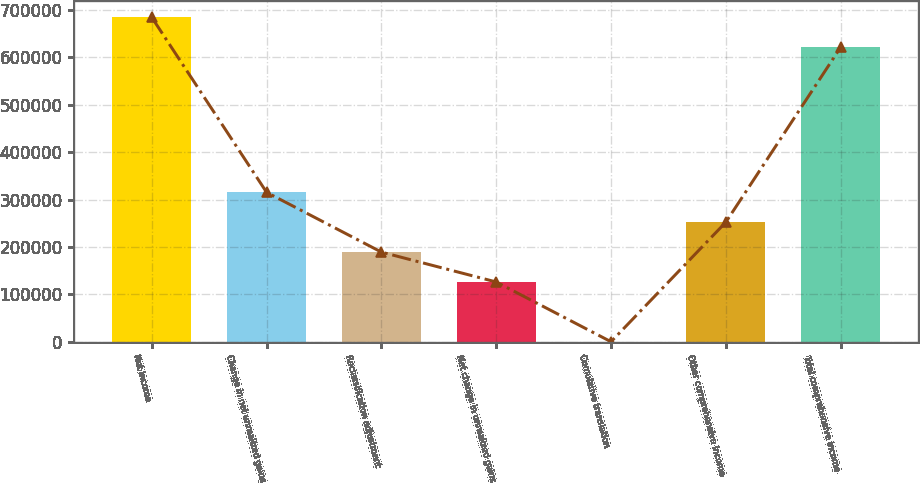Convert chart. <chart><loc_0><loc_0><loc_500><loc_500><bar_chart><fcel>Net income<fcel>Change in net unrealized gains<fcel>Reclassification adjustment<fcel>Net change in unrealized gains<fcel>Cumulative translation<fcel>Other comprehensive income<fcel>Total comprehensive income<nl><fcel>684215<fcel>315211<fcel>189140<fcel>126105<fcel>34<fcel>252176<fcel>621180<nl></chart> 